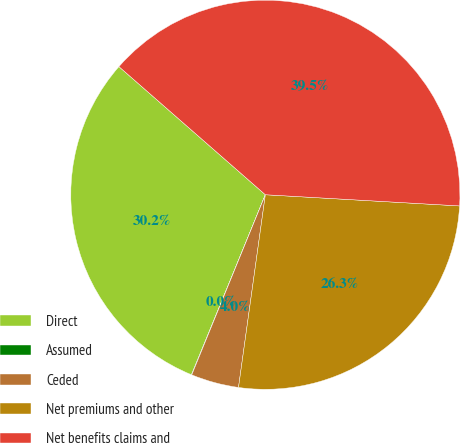Convert chart to OTSL. <chart><loc_0><loc_0><loc_500><loc_500><pie_chart><fcel>Direct<fcel>Assumed<fcel>Ceded<fcel>Net premiums and other<fcel>Net benefits claims and<nl><fcel>30.24%<fcel>0.03%<fcel>3.97%<fcel>26.29%<fcel>39.48%<nl></chart> 